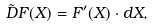Convert formula to latex. <formula><loc_0><loc_0><loc_500><loc_500>\tilde { D } F ( X ) = F ^ { \prime } ( X ) \cdot d X ,</formula> 